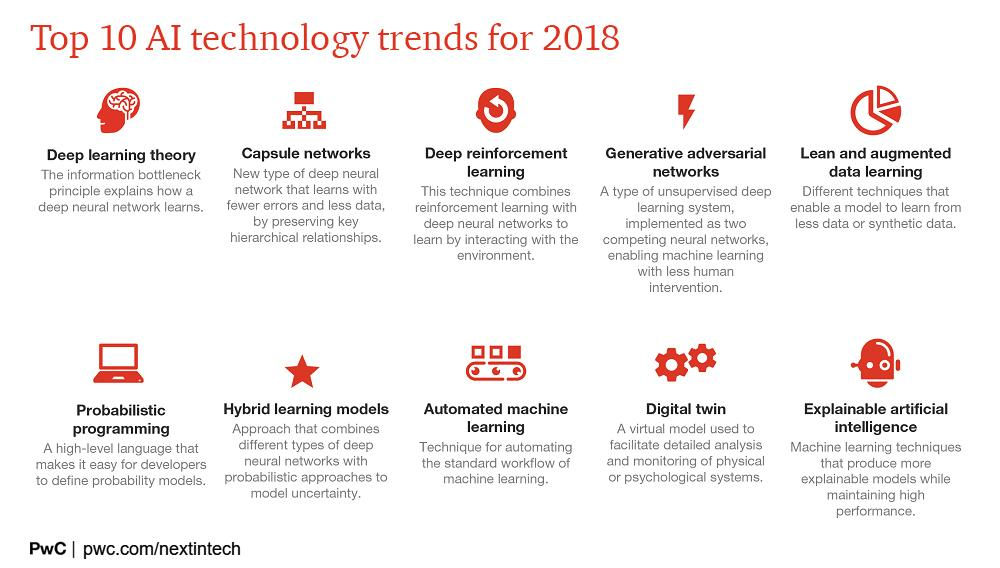Mention a couple of crucial points in this snapshot. Automated machine learning is a technique for automating the workflow of machine learning by using algorithms and models to learn from data and make predictions or decisions without human intervention. Probabilistic programming is a high-level language that assists developers in defining probability models. Models can learn from less data or synthetic data using techniques such as transfer learning and data augmentation. Capsule networks are a type of artificial neural network that use a hierarchical structure to learn and make predictions, while also reducing errors and requiring less data than traditional neural networks. A virtual model, known as a digital twin, is utilized to facilitate the analysis and monitoring of psychological systems. 